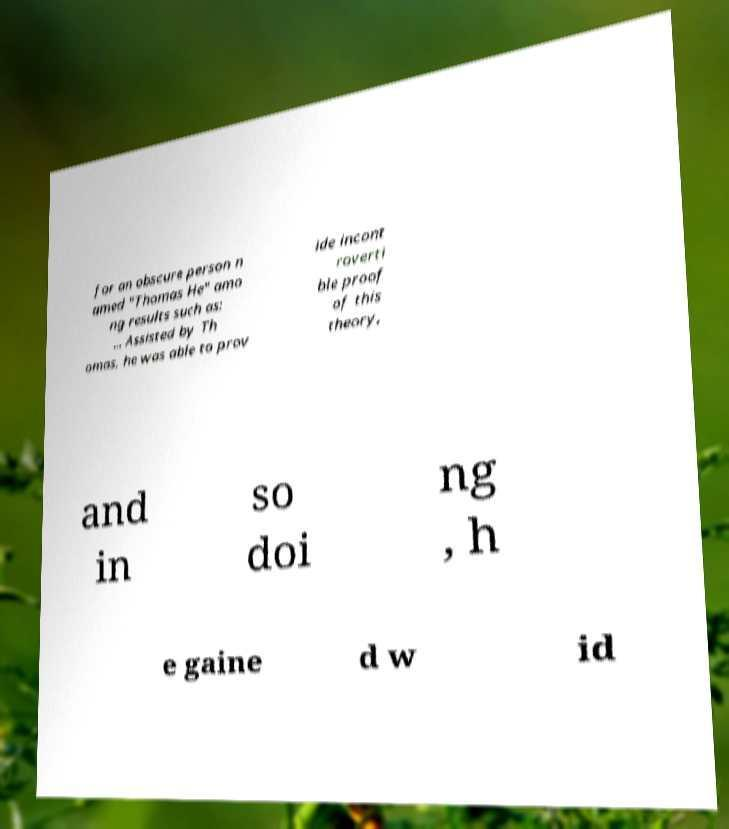For documentation purposes, I need the text within this image transcribed. Could you provide that? for an obscure person n amed "Thomas He" amo ng results such as: ... Assisted by Th omas, he was able to prov ide incont roverti ble proof of this theory, and in so doi ng , h e gaine d w id 